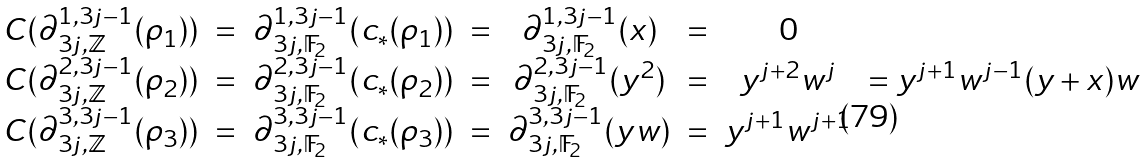Convert formula to latex. <formula><loc_0><loc_0><loc_500><loc_500>\begin{array} { c c c c c c c c } C ( \partial _ { 3 j , \mathbb { \mathbb { Z } } } ^ { 1 , 3 j - 1 } ( \rho _ { 1 } ) ) & = & \partial _ { 3 j , \mathbb { F } _ { 2 } } ^ { 1 , 3 j - 1 } ( c _ { * } ( \rho _ { 1 } ) ) & = & \partial _ { 3 j , \mathbb { F } _ { 2 } } ^ { 1 , 3 j - 1 } ( x ) & = & 0 & \\ C ( \partial _ { 3 j , \mathbb { \mathbb { Z } } } ^ { 2 , 3 j - 1 } ( \rho _ { 2 } ) ) & = & \partial _ { 3 j , \mathbb { F } _ { 2 } } ^ { 2 , 3 j - 1 } ( c _ { * } ( \rho _ { 2 } ) ) & = & \partial _ { 3 j , \mathbb { F } _ { 2 } } ^ { 2 , 3 j - 1 } ( y ^ { 2 } ) & = & y ^ { j + 2 } w ^ { j } & = y ^ { j + 1 } w ^ { j - 1 } ( y + x ) w \\ C ( \partial _ { 3 j , \mathbb { Z } } ^ { 3 , 3 j - 1 } ( \rho _ { 3 } ) ) & = & \partial _ { 3 j , \mathbb { F } _ { 2 } } ^ { 3 , 3 j - 1 } ( c _ { * } ( \rho _ { 3 } ) ) & = & \partial _ { 3 j , \mathbb { F } _ { 2 } } ^ { 3 , 3 j - 1 } ( y w ) & = & y ^ { j + 1 } w ^ { j + 1 } & \end{array}</formula> 